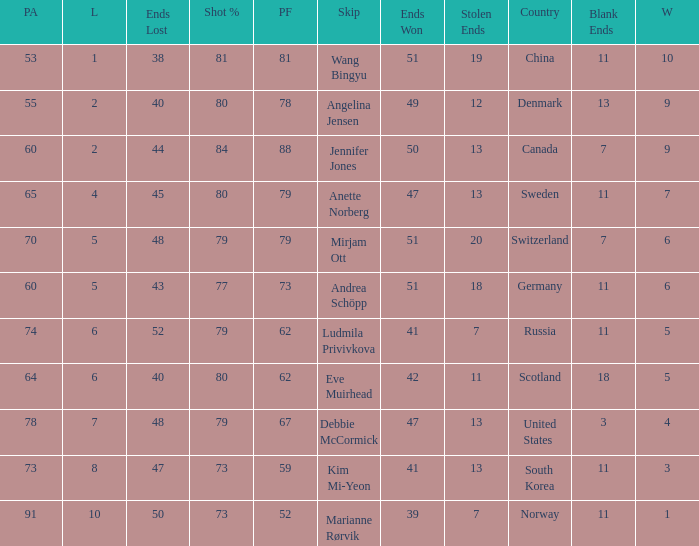Andrea Schöpp is the skip of which country? Germany. 